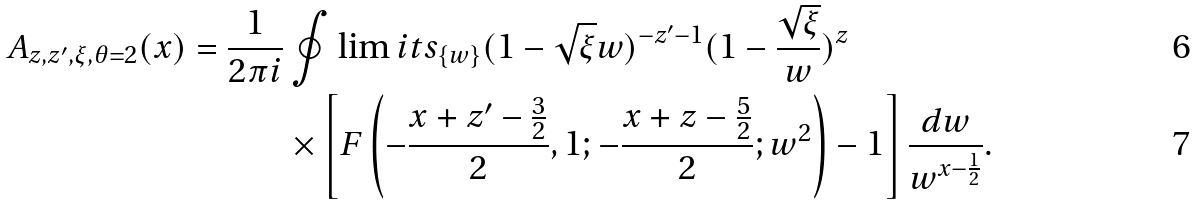<formula> <loc_0><loc_0><loc_500><loc_500>A _ { z , z ^ { \prime } , \xi , \theta = 2 } ( x ) = \frac { 1 } { 2 \pi i } & \oint \lim i t s _ { \{ w \} } ( 1 - \sqrt { \xi } w ) ^ { - z ^ { \prime } - 1 } ( 1 - \frac { \sqrt { \xi } } { w } ) ^ { z } \\ & \times \left [ F \left ( - \frac { x + z ^ { \prime } - \frac { 3 } { 2 } } { 2 } , 1 ; - \frac { x + z - \frac { 5 } { 2 } } { 2 } ; w ^ { 2 } \right ) - 1 \right ] \frac { d w } { w ^ { x - \frac { 1 } { 2 } } } .</formula> 